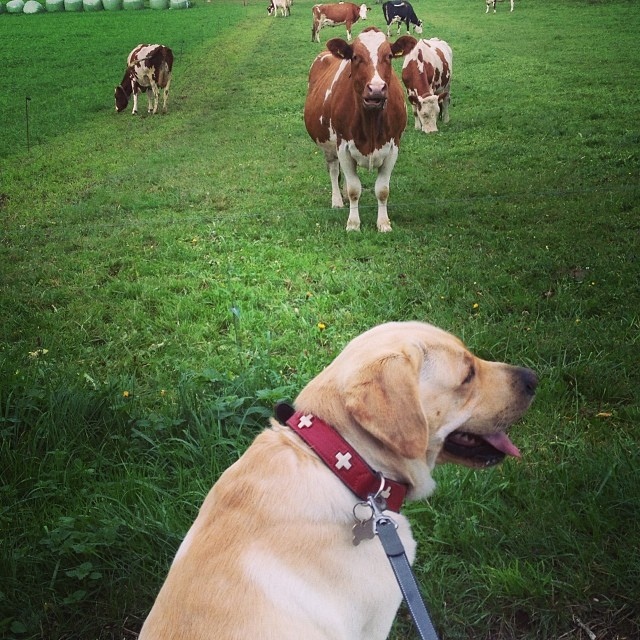<image>Which holiday season is it? The holiday season is not clearly defined. It could be 'July 4th', 'Summer', 'Easter', or 'Christmas'. Which holiday season is it? I am not sure which holiday season it is. It can be either July 4th, Easter or Christmas. 